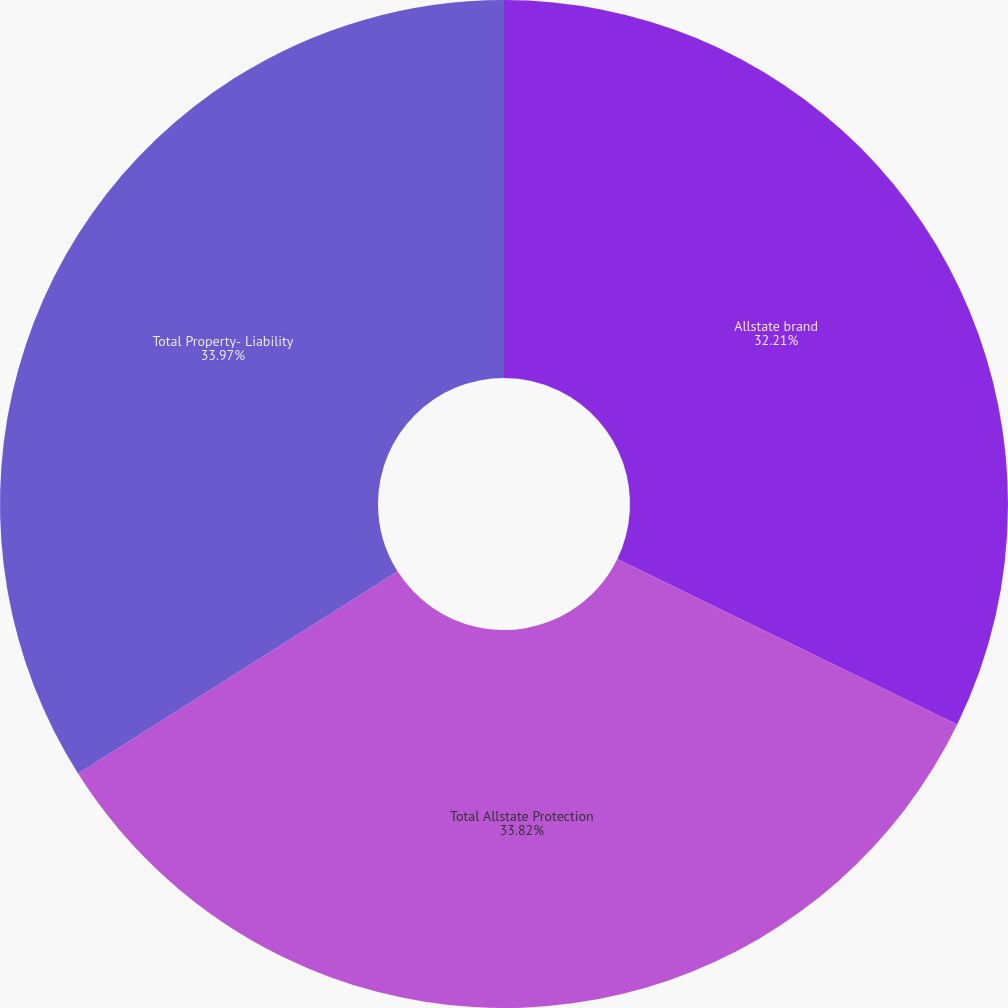Convert chart to OTSL. <chart><loc_0><loc_0><loc_500><loc_500><pie_chart><fcel>Allstate brand<fcel>Total Allstate Protection<fcel>Total Property- Liability<nl><fcel>32.21%<fcel>33.82%<fcel>33.98%<nl></chart> 